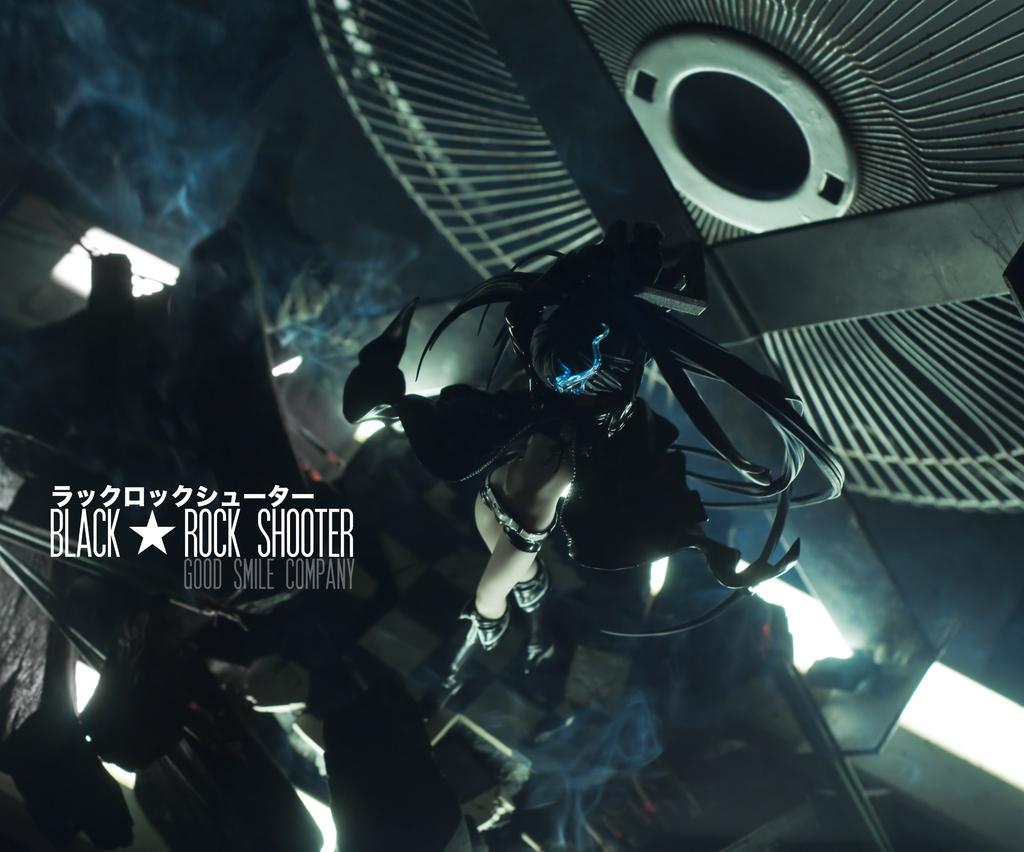What is the name on this poster?
Offer a very short reply. Black rock shooter. What is the company name?
Provide a succinct answer. Good smile company. 